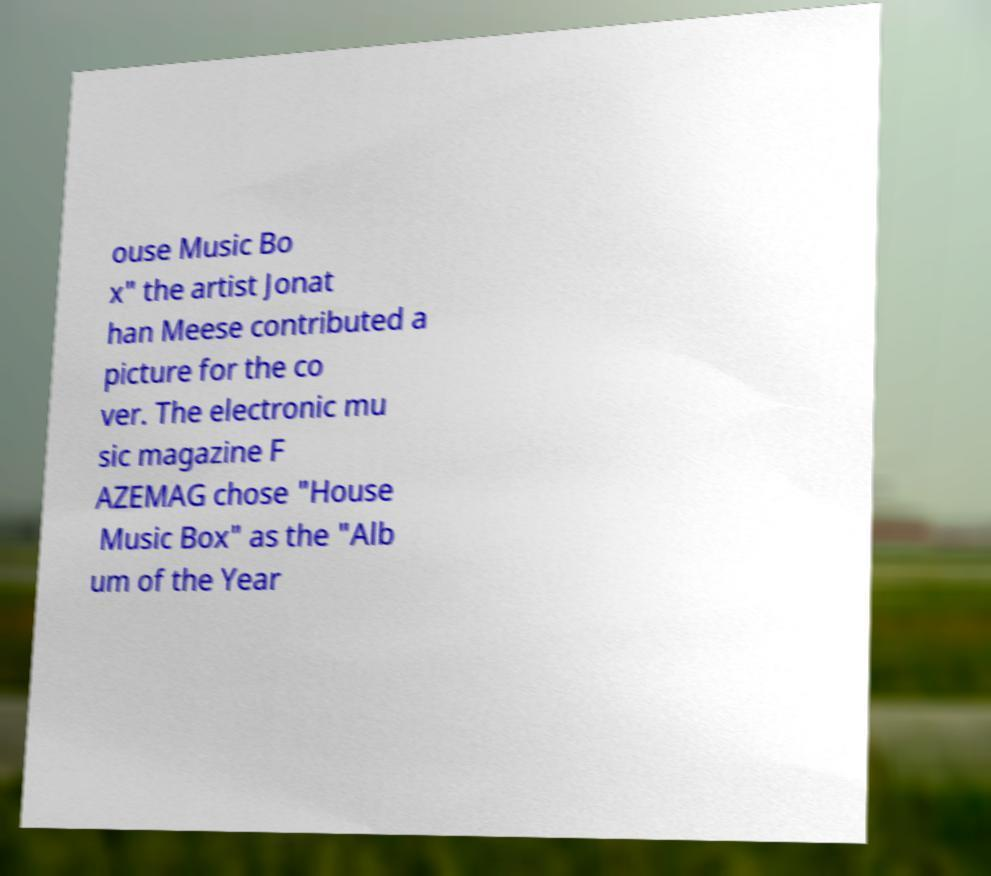I need the written content from this picture converted into text. Can you do that? ouse Music Bo x" the artist Jonat han Meese contributed a picture for the co ver. The electronic mu sic magazine F AZEMAG chose "House Music Box" as the "Alb um of the Year 